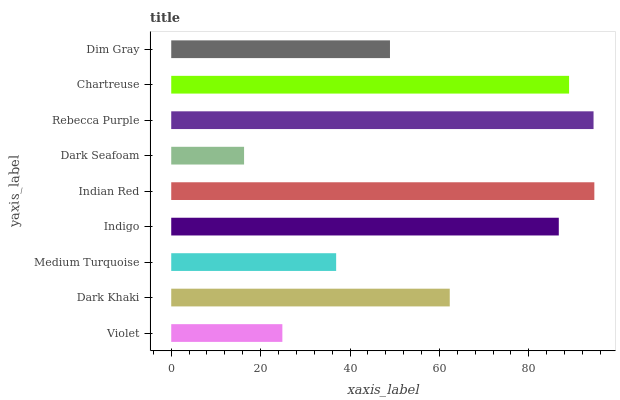Is Dark Seafoam the minimum?
Answer yes or no. Yes. Is Indian Red the maximum?
Answer yes or no. Yes. Is Dark Khaki the minimum?
Answer yes or no. No. Is Dark Khaki the maximum?
Answer yes or no. No. Is Dark Khaki greater than Violet?
Answer yes or no. Yes. Is Violet less than Dark Khaki?
Answer yes or no. Yes. Is Violet greater than Dark Khaki?
Answer yes or no. No. Is Dark Khaki less than Violet?
Answer yes or no. No. Is Dark Khaki the high median?
Answer yes or no. Yes. Is Dark Khaki the low median?
Answer yes or no. Yes. Is Indian Red the high median?
Answer yes or no. No. Is Rebecca Purple the low median?
Answer yes or no. No. 